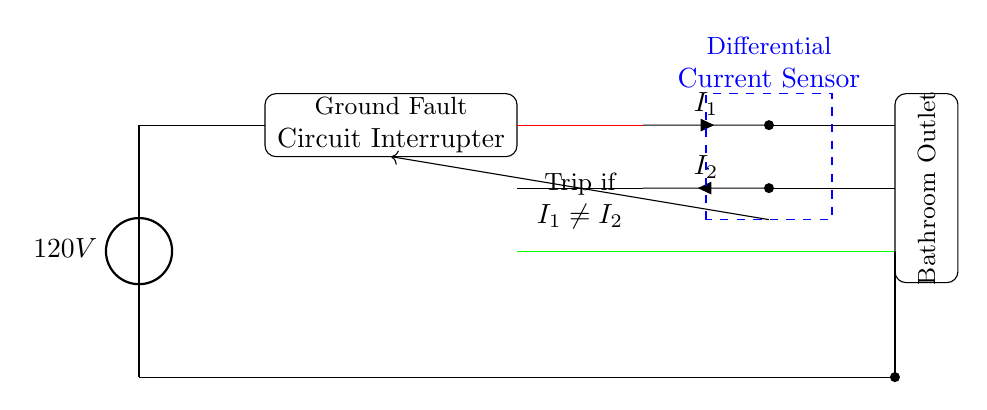What is the voltage of this circuit? The voltage is 120V, which is indicated by the voltage source on the left side of the diagram.
Answer: 120V What type of sensor is present in this circuit? The circuit includes a differential current sensor, which is shown within a dashed rectangle in blue. It is responsible for detecting any imbalance between the hot and neutral wires.
Answer: Differential current sensor How many wires are used in this circuit? There are three types of wires depicted: one hot wire, one neutral wire, and one ground wire, totaling three wires for power and safety.
Answer: Three What happens if the currents are not equal? If the currents are not equal (I1 ≠ I2), the circuit will trip as indicated by the arrow pointing to the trip mechanism, which will disconnect power to prevent electrical shocks.
Answer: Trip What is the purpose of the ground wire? The ground wire serves as a safety path to prevent electric shock by directing excess current safely to the ground in case of a fault.
Answer: Safety path How does the ground fault circuit interrupter (GFCI) work? The GFCI continuously monitors the current flowing through the hot and neutral wires; if it detects a difference (leakage), it trips and cuts off the circuit to prevent shocks, ensuring safety in wet areas such as bathrooms.
Answer: Monitors current difference 